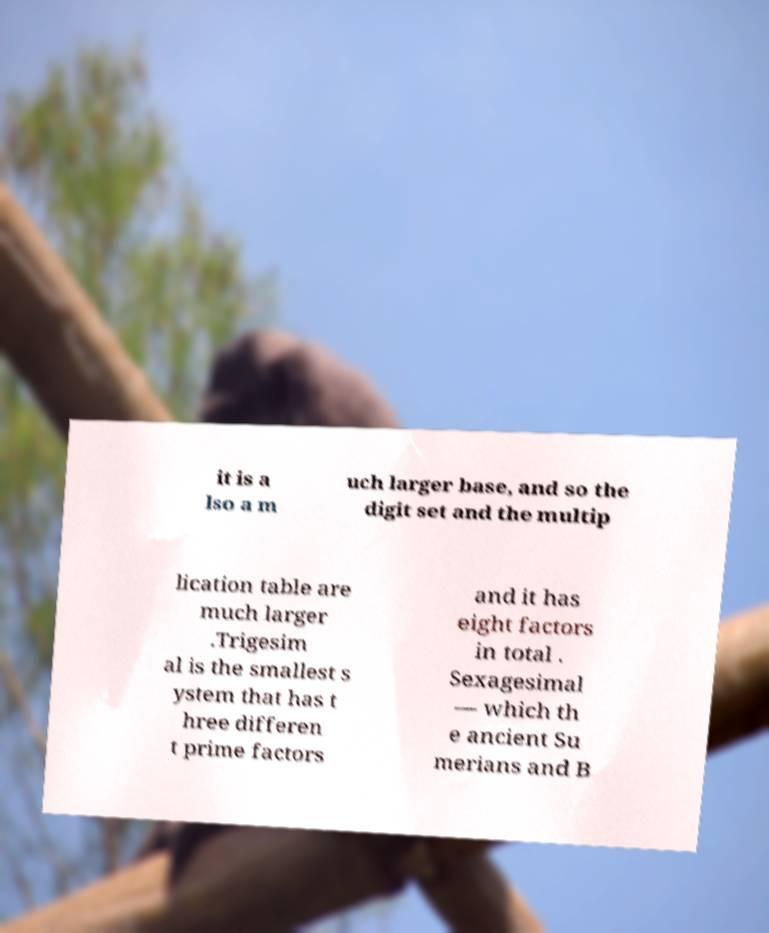Can you accurately transcribe the text from the provided image for me? it is a lso a m uch larger base, and so the digit set and the multip lication table are much larger .Trigesim al is the smallest s ystem that has t hree differen t prime factors and it has eight factors in total . Sexagesimal — which th e ancient Su merians and B 